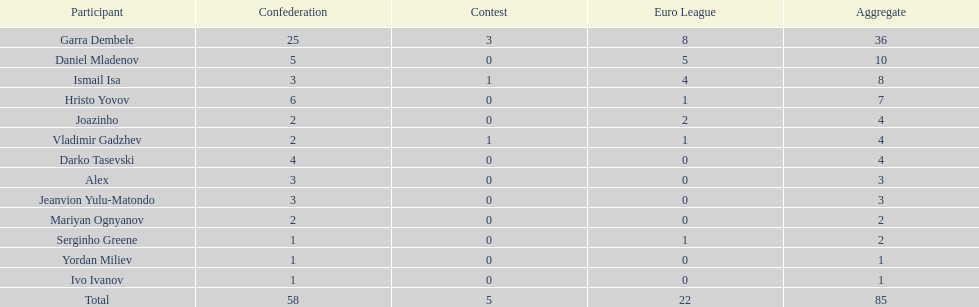Which total is higher, the europa league total or the league total? League. 